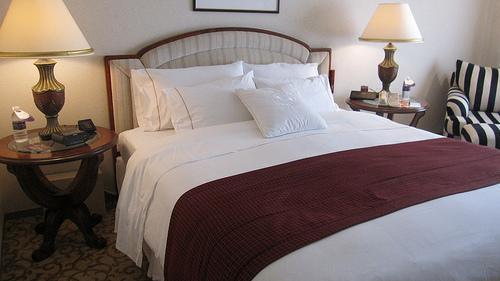How many pillows are there?
Give a very brief answer. 5. 